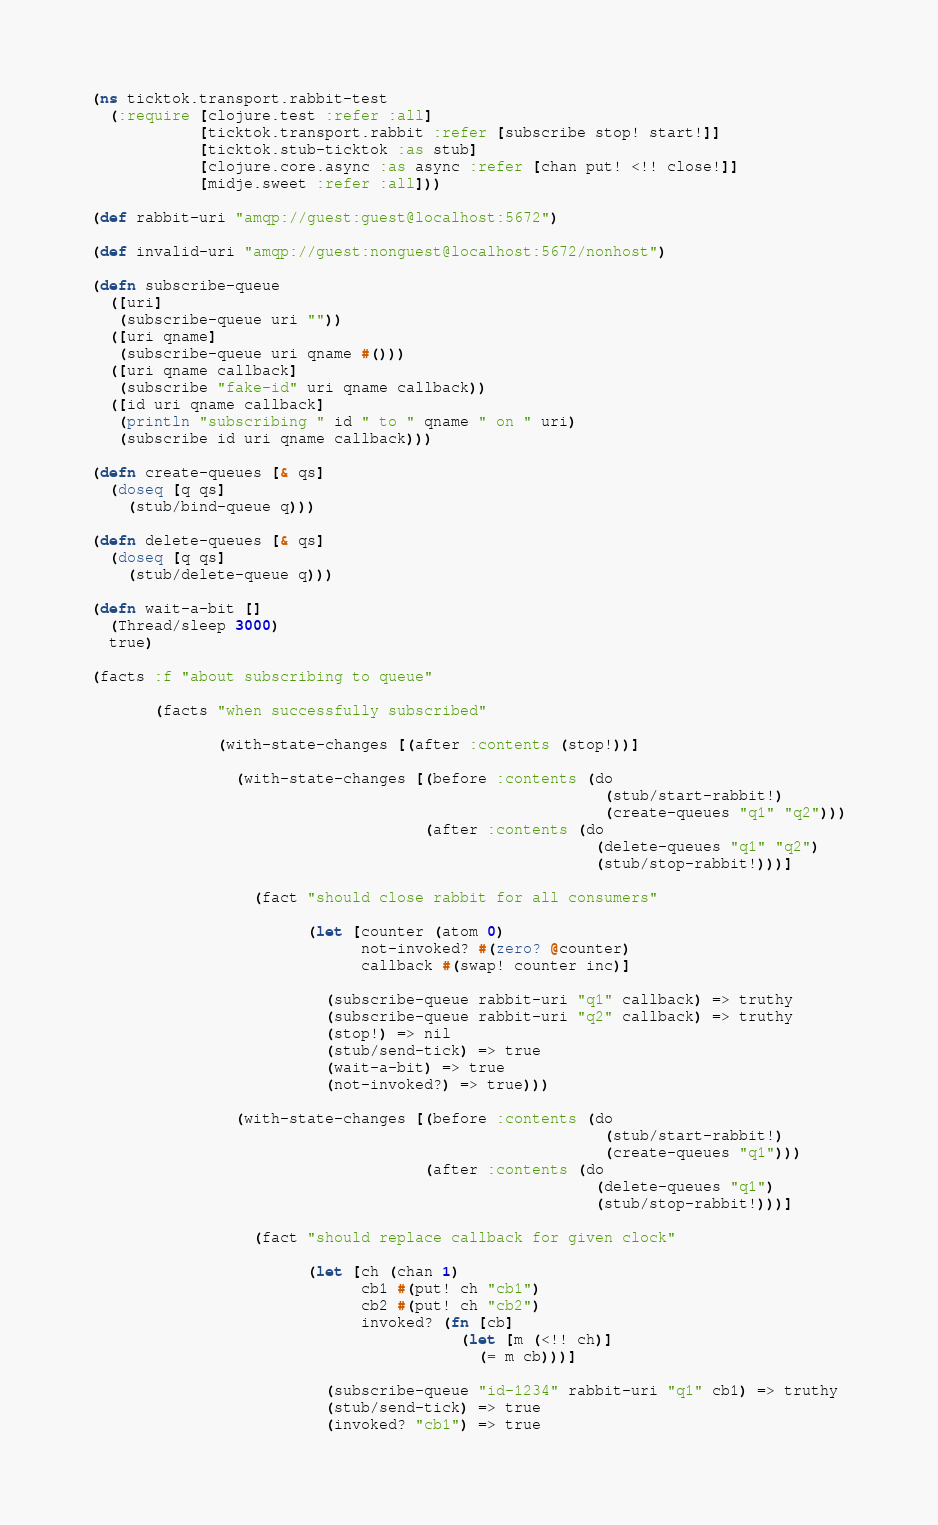<code> <loc_0><loc_0><loc_500><loc_500><_Clojure_>(ns ticktok.transport.rabbit-test
  (:require [clojure.test :refer :all]
            [ticktok.transport.rabbit :refer [subscribe stop! start!]]
            [ticktok.stub-ticktok :as stub]
            [clojure.core.async :as async :refer [chan put! <!! close!]]
            [midje.sweet :refer :all]))

(def rabbit-uri "amqp://guest:guest@localhost:5672")

(def invalid-uri "amqp://guest:nonguest@localhost:5672/nonhost")

(defn subscribe-queue
  ([uri]
   (subscribe-queue uri ""))
  ([uri qname]
   (subscribe-queue uri qname #()))
  ([uri qname callback]
   (subscribe "fake-id" uri qname callback))
  ([id uri qname callback]
   (println "subscribing " id " to " qname " on " uri)
   (subscribe id uri qname callback)))

(defn create-queues [& qs]
  (doseq [q qs]
    (stub/bind-queue q)))

(defn delete-queues [& qs]
  (doseq [q qs]
    (stub/delete-queue q)))

(defn wait-a-bit []
  (Thread/sleep 3000)
  true)

(facts :f "about subscribing to queue"

       (facts "when successfully subscribed"

              (with-state-changes [(after :contents (stop!))]

                (with-state-changes [(before :contents (do
                                                         (stub/start-rabbit!)
                                                         (create-queues "q1" "q2")))
                                     (after :contents (do
                                                        (delete-queues "q1" "q2")
                                                        (stub/stop-rabbit!)))]

                  (fact "should close rabbit for all consumers"

                        (let [counter (atom 0)
                              not-invoked? #(zero? @counter)
                              callback #(swap! counter inc)]

                          (subscribe-queue rabbit-uri "q1" callback) => truthy
                          (subscribe-queue rabbit-uri "q2" callback) => truthy
                          (stop!) => nil
                          (stub/send-tick) => true
                          (wait-a-bit) => true
                          (not-invoked?) => true)))

                (with-state-changes [(before :contents (do
                                                         (stub/start-rabbit!)
                                                         (create-queues "q1")))
                                     (after :contents (do
                                                        (delete-queues "q1")
                                                        (stub/stop-rabbit!)))]

                  (fact "should replace callback for given clock"

                        (let [ch (chan 1)
                              cb1 #(put! ch "cb1")
                              cb2 #(put! ch "cb2")
                              invoked? (fn [cb]
                                         (let [m (<!! ch)]
                                           (= m cb)))]

                          (subscribe-queue "id-1234" rabbit-uri "q1" cb1) => truthy
                          (stub/send-tick) => true
                          (invoked? "cb1") => true</code> 